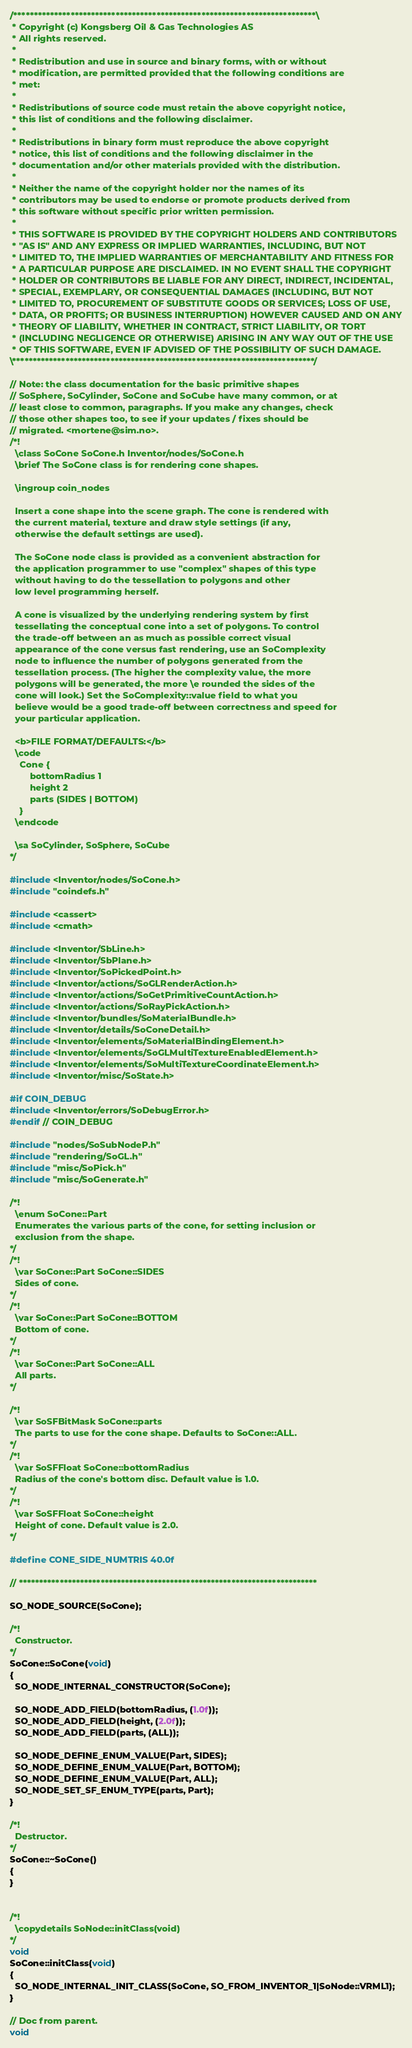<code> <loc_0><loc_0><loc_500><loc_500><_C++_>/**************************************************************************\
 * Copyright (c) Kongsberg Oil & Gas Technologies AS
 * All rights reserved.
 * 
 * Redistribution and use in source and binary forms, with or without
 * modification, are permitted provided that the following conditions are
 * met:
 * 
 * Redistributions of source code must retain the above copyright notice,
 * this list of conditions and the following disclaimer.
 * 
 * Redistributions in binary form must reproduce the above copyright
 * notice, this list of conditions and the following disclaimer in the
 * documentation and/or other materials provided with the distribution.
 * 
 * Neither the name of the copyright holder nor the names of its
 * contributors may be used to endorse or promote products derived from
 * this software without specific prior written permission.
 * 
 * THIS SOFTWARE IS PROVIDED BY THE COPYRIGHT HOLDERS AND CONTRIBUTORS
 * "AS IS" AND ANY EXPRESS OR IMPLIED WARRANTIES, INCLUDING, BUT NOT
 * LIMITED TO, THE IMPLIED WARRANTIES OF MERCHANTABILITY AND FITNESS FOR
 * A PARTICULAR PURPOSE ARE DISCLAIMED. IN NO EVENT SHALL THE COPYRIGHT
 * HOLDER OR CONTRIBUTORS BE LIABLE FOR ANY DIRECT, INDIRECT, INCIDENTAL,
 * SPECIAL, EXEMPLARY, OR CONSEQUENTIAL DAMAGES (INCLUDING, BUT NOT
 * LIMITED TO, PROCUREMENT OF SUBSTITUTE GOODS OR SERVICES; LOSS OF USE,
 * DATA, OR PROFITS; OR BUSINESS INTERRUPTION) HOWEVER CAUSED AND ON ANY
 * THEORY OF LIABILITY, WHETHER IN CONTRACT, STRICT LIABILITY, OR TORT
 * (INCLUDING NEGLIGENCE OR OTHERWISE) ARISING IN ANY WAY OUT OF THE USE
 * OF THIS SOFTWARE, EVEN IF ADVISED OF THE POSSIBILITY OF SUCH DAMAGE.
\**************************************************************************/

// Note: the class documentation for the basic primitive shapes
// SoSphere, SoCylinder, SoCone and SoCube have many common, or at
// least close to common, paragraphs. If you make any changes, check
// those other shapes too, to see if your updates / fixes should be
// migrated. <mortene@sim.no>.
/*!
  \class SoCone SoCone.h Inventor/nodes/SoCone.h
  \brief The SoCone class is for rendering cone shapes.

  \ingroup coin_nodes

  Insert a cone shape into the scene graph. The cone is rendered with
  the current material, texture and draw style settings (if any,
  otherwise the default settings are used).

  The SoCone node class is provided as a convenient abstraction for
  the application programmer to use "complex" shapes of this type
  without having to do the tessellation to polygons and other
  low level programming herself.

  A cone is visualized by the underlying rendering system by first
  tessellating the conceptual cone into a set of polygons. To control
  the trade-off between an as much as possible correct visual
  appearance of the cone versus fast rendering, use an SoComplexity
  node to influence the number of polygons generated from the
  tessellation process. (The higher the complexity value, the more
  polygons will be generated, the more \e rounded the sides of the
  cone will look.) Set the SoComplexity::value field to what you
  believe would be a good trade-off between correctness and speed for
  your particular application.

  <b>FILE FORMAT/DEFAULTS:</b>
  \code
    Cone {
        bottomRadius 1
        height 2
        parts (SIDES | BOTTOM)
    }
  \endcode

  \sa SoCylinder, SoSphere, SoCube
*/

#include <Inventor/nodes/SoCone.h>
#include "coindefs.h"

#include <cassert>
#include <cmath>

#include <Inventor/SbLine.h>
#include <Inventor/SbPlane.h>
#include <Inventor/SoPickedPoint.h>
#include <Inventor/actions/SoGLRenderAction.h>
#include <Inventor/actions/SoGetPrimitiveCountAction.h>
#include <Inventor/actions/SoRayPickAction.h>
#include <Inventor/bundles/SoMaterialBundle.h>
#include <Inventor/details/SoConeDetail.h>
#include <Inventor/elements/SoMaterialBindingElement.h>
#include <Inventor/elements/SoGLMultiTextureEnabledElement.h>
#include <Inventor/elements/SoMultiTextureCoordinateElement.h>
#include <Inventor/misc/SoState.h>

#if COIN_DEBUG
#include <Inventor/errors/SoDebugError.h>
#endif // COIN_DEBUG

#include "nodes/SoSubNodeP.h"
#include "rendering/SoGL.h"
#include "misc/SoPick.h"
#include "misc/SoGenerate.h"

/*!
  \enum SoCone::Part
  Enumerates the various parts of the cone, for setting inclusion or
  exclusion from the shape.
*/
/*!
  \var SoCone::Part SoCone::SIDES
  Sides of cone.
*/
/*!
  \var SoCone::Part SoCone::BOTTOM
  Bottom of cone.
*/
/*!
  \var SoCone::Part SoCone::ALL
  All parts.
*/

/*!
  \var SoSFBitMask SoCone::parts
  The parts to use for the cone shape. Defaults to SoCone::ALL.
*/
/*!
  \var SoSFFloat SoCone::bottomRadius
  Radius of the cone's bottom disc. Default value is 1.0.
*/
/*!
  \var SoSFFloat SoCone::height
  Height of cone. Default value is 2.0.
*/

#define CONE_SIDE_NUMTRIS 40.0f

// *************************************************************************

SO_NODE_SOURCE(SoCone);

/*!
  Constructor.
*/
SoCone::SoCone(void)
{
  SO_NODE_INTERNAL_CONSTRUCTOR(SoCone);

  SO_NODE_ADD_FIELD(bottomRadius, (1.0f));
  SO_NODE_ADD_FIELD(height, (2.0f));
  SO_NODE_ADD_FIELD(parts, (ALL));

  SO_NODE_DEFINE_ENUM_VALUE(Part, SIDES);
  SO_NODE_DEFINE_ENUM_VALUE(Part, BOTTOM);
  SO_NODE_DEFINE_ENUM_VALUE(Part, ALL);
  SO_NODE_SET_SF_ENUM_TYPE(parts, Part);
}

/*!
  Destructor.
*/
SoCone::~SoCone()
{
}


/*!
  \copydetails SoNode::initClass(void)
*/
void
SoCone::initClass(void)
{
  SO_NODE_INTERNAL_INIT_CLASS(SoCone, SO_FROM_INVENTOR_1|SoNode::VRML1);
}

// Doc from parent.
void</code> 